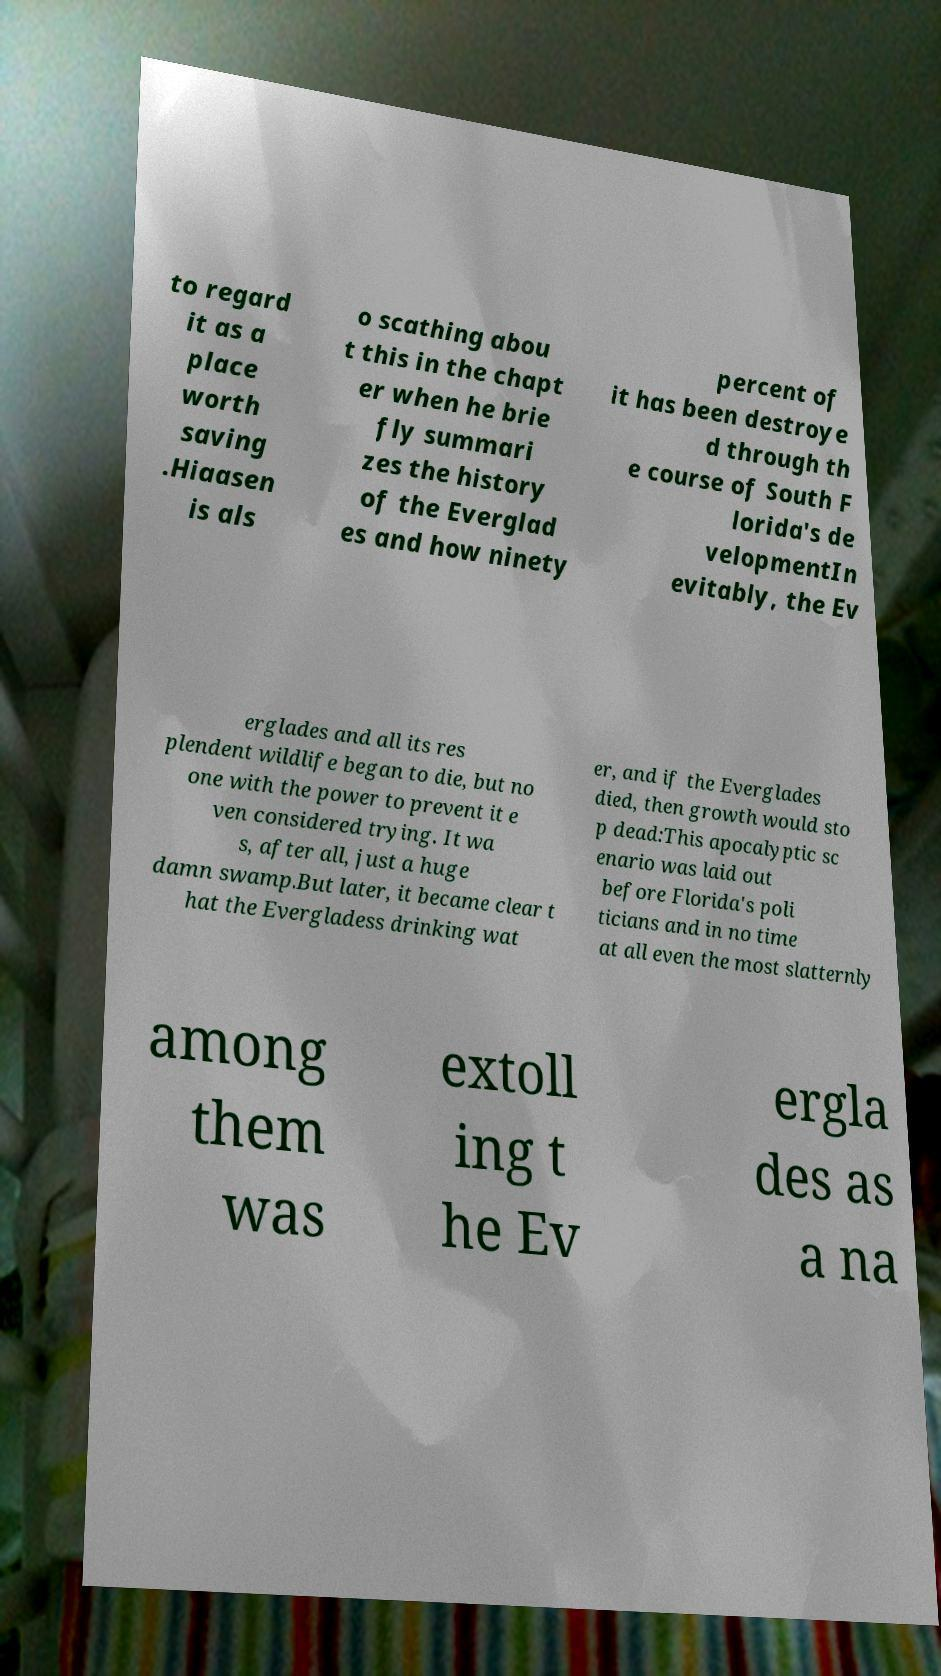I need the written content from this picture converted into text. Can you do that? to regard it as a place worth saving .Hiaasen is als o scathing abou t this in the chapt er when he brie fly summari zes the history of the Everglad es and how ninety percent of it has been destroye d through th e course of South F lorida's de velopmentIn evitably, the Ev erglades and all its res plendent wildlife began to die, but no one with the power to prevent it e ven considered trying. It wa s, after all, just a huge damn swamp.But later, it became clear t hat the Evergladess drinking wat er, and if the Everglades died, then growth would sto p dead:This apocalyptic sc enario was laid out before Florida's poli ticians and in no time at all even the most slatternly among them was extoll ing t he Ev ergla des as a na 